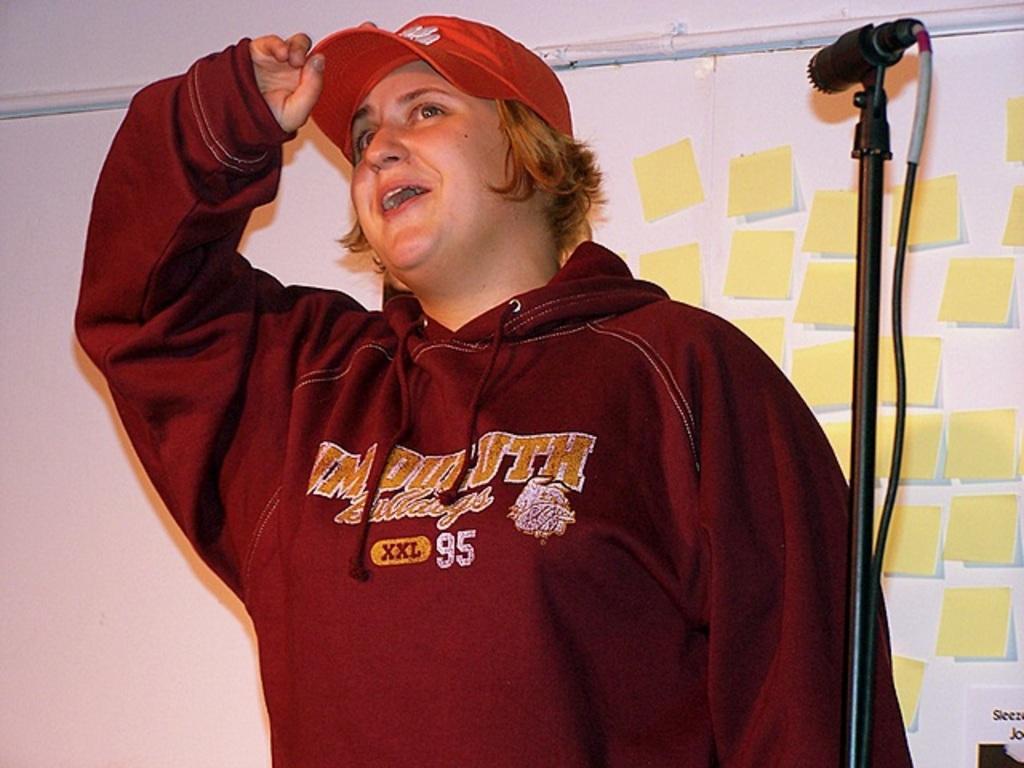How would you summarize this image in a sentence or two? In this image there is a person wearing a cap is standing near the mike stand. Behind him there are few papers attached to the wall. 